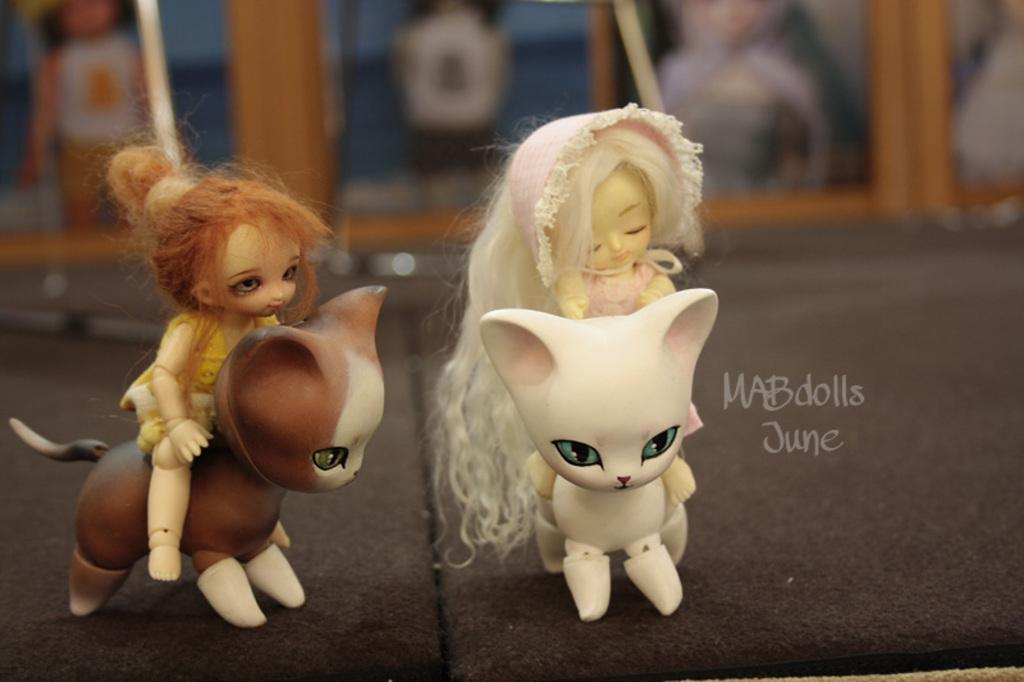What objects can be seen on the surface in the image? There are toys on the surface in the image. What else can be observed in the image besides the toys? There is text visible in the image. How would you describe the background of the image? The background of the image is blurry. Can you tell me what type of ornament is hanging from the tree in the image? There is no tree or ornament present in the image; it only features toys and text on a blurry background. 